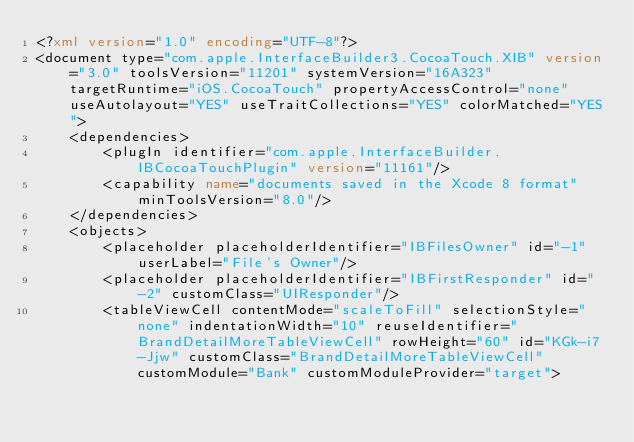Convert code to text. <code><loc_0><loc_0><loc_500><loc_500><_XML_><?xml version="1.0" encoding="UTF-8"?>
<document type="com.apple.InterfaceBuilder3.CocoaTouch.XIB" version="3.0" toolsVersion="11201" systemVersion="16A323" targetRuntime="iOS.CocoaTouch" propertyAccessControl="none" useAutolayout="YES" useTraitCollections="YES" colorMatched="YES">
    <dependencies>
        <plugIn identifier="com.apple.InterfaceBuilder.IBCocoaTouchPlugin" version="11161"/>
        <capability name="documents saved in the Xcode 8 format" minToolsVersion="8.0"/>
    </dependencies>
    <objects>
        <placeholder placeholderIdentifier="IBFilesOwner" id="-1" userLabel="File's Owner"/>
        <placeholder placeholderIdentifier="IBFirstResponder" id="-2" customClass="UIResponder"/>
        <tableViewCell contentMode="scaleToFill" selectionStyle="none" indentationWidth="10" reuseIdentifier="BrandDetailMoreTableViewCell" rowHeight="60" id="KGk-i7-Jjw" customClass="BrandDetailMoreTableViewCell" customModule="Bank" customModuleProvider="target"></code> 